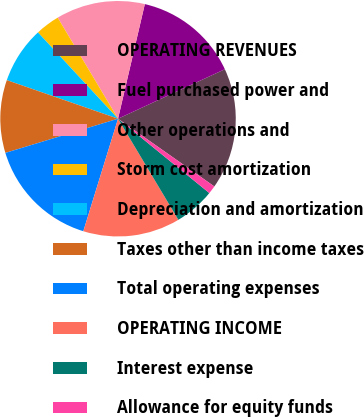<chart> <loc_0><loc_0><loc_500><loc_500><pie_chart><fcel>OPERATING REVENUES<fcel>Fuel purchased power and<fcel>Other operations and<fcel>Storm cost amortization<fcel>Depreciation and amortization<fcel>Taxes other than income taxes<fcel>Total operating expenses<fcel>OPERATING INCOME<fcel>Interest expense<fcel>Allowance for equity funds<nl><fcel>16.66%<fcel>14.44%<fcel>12.22%<fcel>3.34%<fcel>7.78%<fcel>10.0%<fcel>15.55%<fcel>13.33%<fcel>5.56%<fcel>1.12%<nl></chart> 